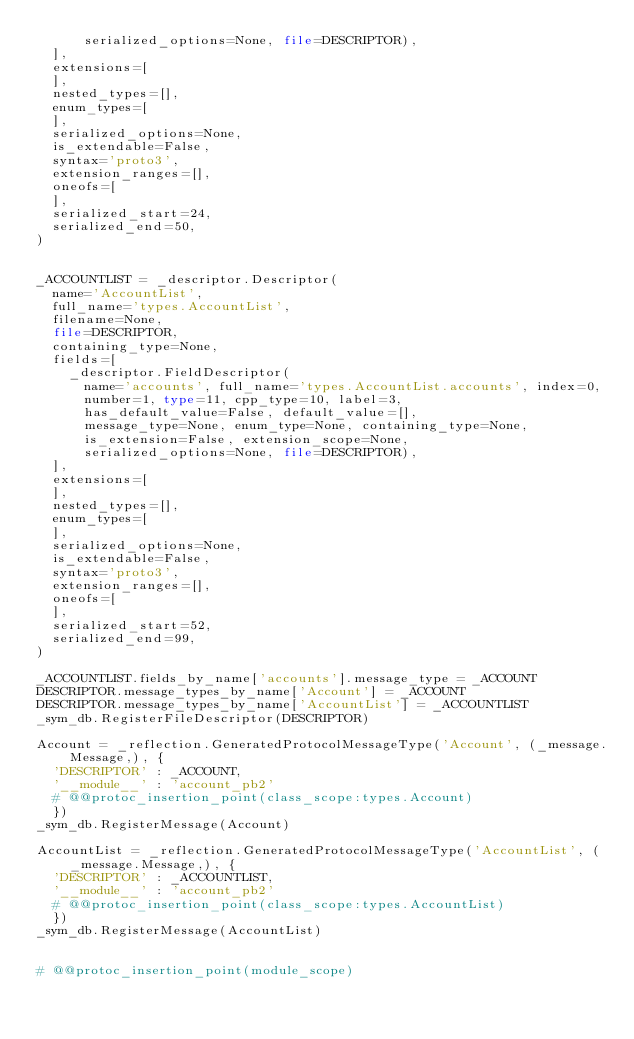Convert code to text. <code><loc_0><loc_0><loc_500><loc_500><_Python_>      serialized_options=None, file=DESCRIPTOR),
  ],
  extensions=[
  ],
  nested_types=[],
  enum_types=[
  ],
  serialized_options=None,
  is_extendable=False,
  syntax='proto3',
  extension_ranges=[],
  oneofs=[
  ],
  serialized_start=24,
  serialized_end=50,
)


_ACCOUNTLIST = _descriptor.Descriptor(
  name='AccountList',
  full_name='types.AccountList',
  filename=None,
  file=DESCRIPTOR,
  containing_type=None,
  fields=[
    _descriptor.FieldDescriptor(
      name='accounts', full_name='types.AccountList.accounts', index=0,
      number=1, type=11, cpp_type=10, label=3,
      has_default_value=False, default_value=[],
      message_type=None, enum_type=None, containing_type=None,
      is_extension=False, extension_scope=None,
      serialized_options=None, file=DESCRIPTOR),
  ],
  extensions=[
  ],
  nested_types=[],
  enum_types=[
  ],
  serialized_options=None,
  is_extendable=False,
  syntax='proto3',
  extension_ranges=[],
  oneofs=[
  ],
  serialized_start=52,
  serialized_end=99,
)

_ACCOUNTLIST.fields_by_name['accounts'].message_type = _ACCOUNT
DESCRIPTOR.message_types_by_name['Account'] = _ACCOUNT
DESCRIPTOR.message_types_by_name['AccountList'] = _ACCOUNTLIST
_sym_db.RegisterFileDescriptor(DESCRIPTOR)

Account = _reflection.GeneratedProtocolMessageType('Account', (_message.Message,), {
  'DESCRIPTOR' : _ACCOUNT,
  '__module__' : 'account_pb2'
  # @@protoc_insertion_point(class_scope:types.Account)
  })
_sym_db.RegisterMessage(Account)

AccountList = _reflection.GeneratedProtocolMessageType('AccountList', (_message.Message,), {
  'DESCRIPTOR' : _ACCOUNTLIST,
  '__module__' : 'account_pb2'
  # @@protoc_insertion_point(class_scope:types.AccountList)
  })
_sym_db.RegisterMessage(AccountList)


# @@protoc_insertion_point(module_scope)
</code> 